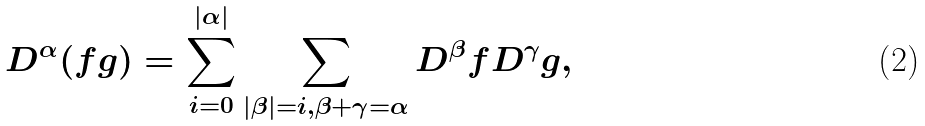Convert formula to latex. <formula><loc_0><loc_0><loc_500><loc_500>D ^ { \alpha } ( f g ) = \sum _ { i = 0 } ^ { | \alpha | } \sum _ { | \beta | = i , \beta + \gamma = \alpha } D ^ { \beta } f D ^ { \gamma } g ,</formula> 